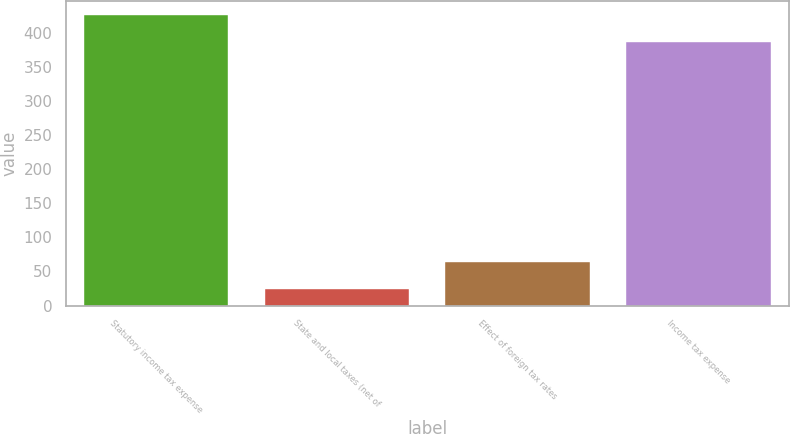Convert chart. <chart><loc_0><loc_0><loc_500><loc_500><bar_chart><fcel>Statutory income tax expense<fcel>State and local taxes (net of<fcel>Effect of foreign tax rates<fcel>Income tax expense<nl><fcel>425.5<fcel>25<fcel>63.5<fcel>387<nl></chart> 